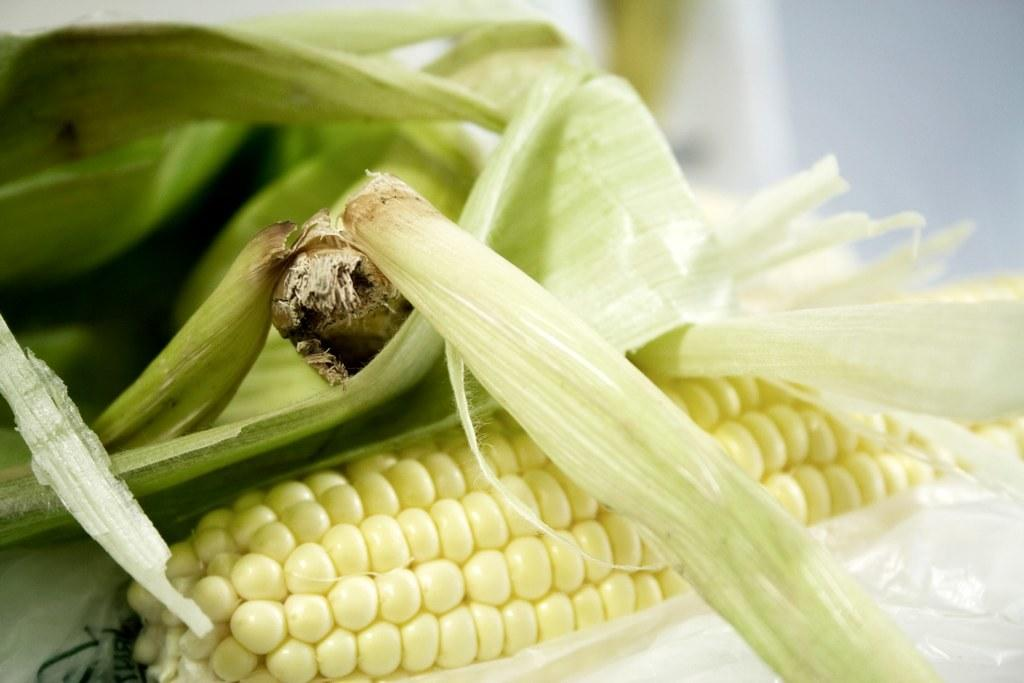What type of vegetable is featured in the image? There is a leaf of sweet corn in the image. Are there any other sweet corn plants visible in the image? Yes, there are sweet corn plants in the image. What type of window can be seen in the image? There is no window present in the image; it features sweet corn leaves and plants. What type of stew is being prepared in the image? There is no stew being prepared in the image; it focuses on sweet corn leaves and plants. 